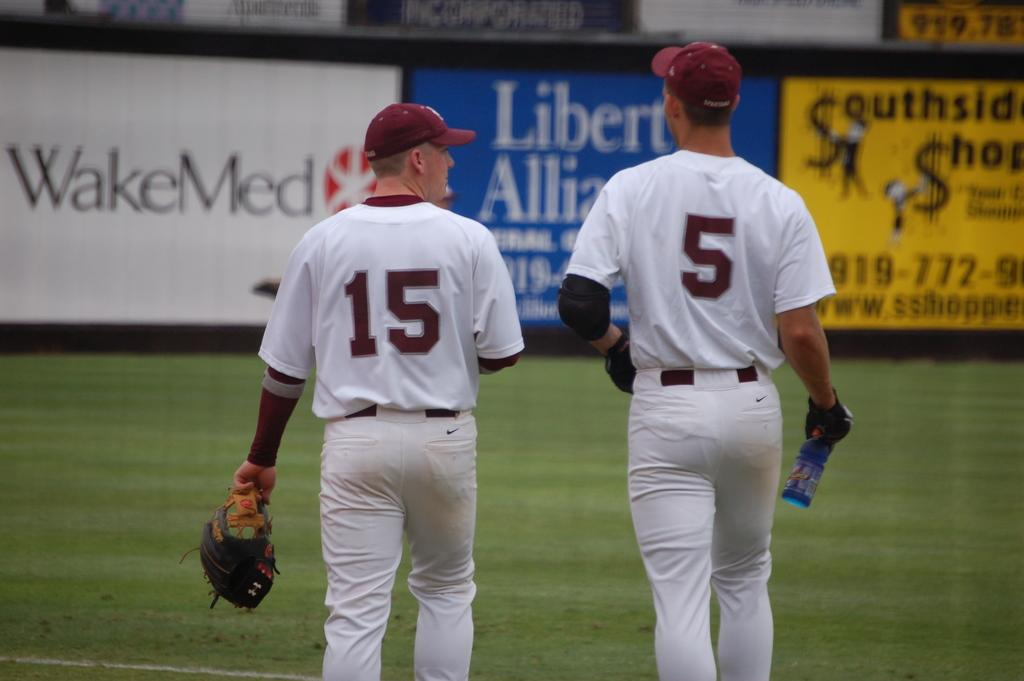Provide a one-sentence caption for the provided image. Two baseball players wearing white uniform and red cap walking on the field. 